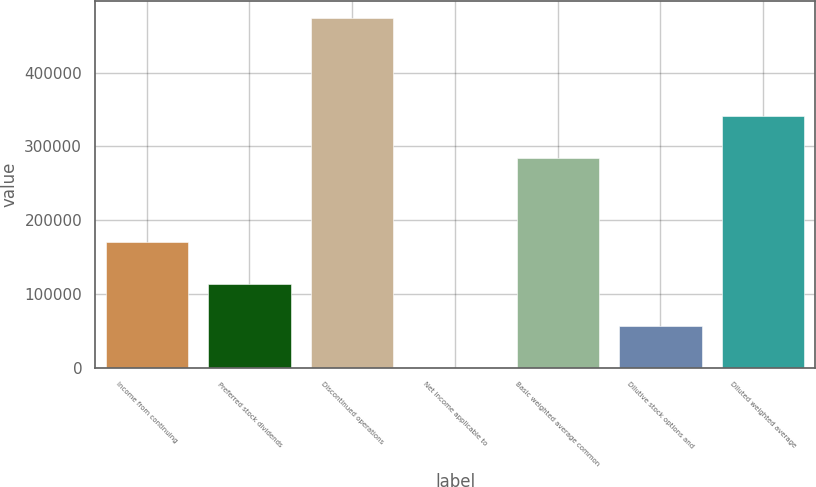<chart> <loc_0><loc_0><loc_500><loc_500><bar_chart><fcel>Income from continuing<fcel>Preferred stock dividends<fcel>Discontinued operations<fcel>Net income applicable to<fcel>Basic weighted average common<fcel>Dilutive stock options and<fcel>Diluted weighted average<nl><fcel>170367<fcel>113579<fcel>473367<fcel>2.73<fcel>283944<fcel>56791<fcel>340732<nl></chart> 